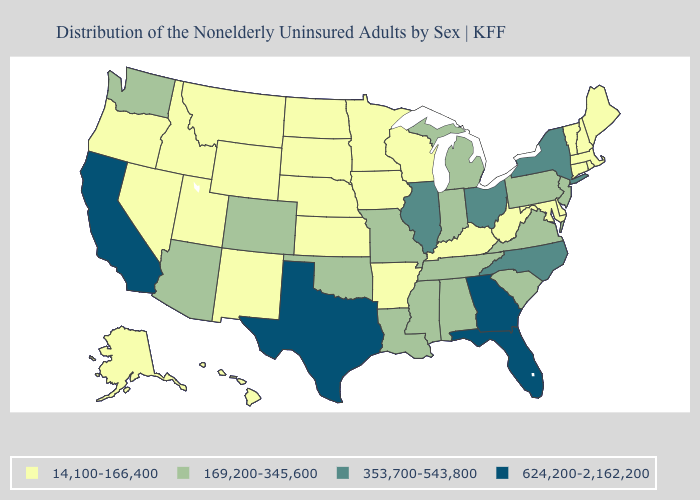What is the value of Arkansas?
Answer briefly. 14,100-166,400. Which states hav the highest value in the West?
Be succinct. California. Does California have the highest value in the West?
Be succinct. Yes. Does Oklahoma have a higher value than Hawaii?
Short answer required. Yes. Does Massachusetts have the lowest value in the Northeast?
Concise answer only. Yes. Which states have the lowest value in the South?
Be succinct. Arkansas, Delaware, Kentucky, Maryland, West Virginia. Name the states that have a value in the range 624,200-2,162,200?
Quick response, please. California, Florida, Georgia, Texas. What is the highest value in the USA?
Quick response, please. 624,200-2,162,200. Does Iowa have a higher value than Montana?
Write a very short answer. No. Name the states that have a value in the range 14,100-166,400?
Keep it brief. Alaska, Arkansas, Connecticut, Delaware, Hawaii, Idaho, Iowa, Kansas, Kentucky, Maine, Maryland, Massachusetts, Minnesota, Montana, Nebraska, Nevada, New Hampshire, New Mexico, North Dakota, Oregon, Rhode Island, South Dakota, Utah, Vermont, West Virginia, Wisconsin, Wyoming. Name the states that have a value in the range 14,100-166,400?
Quick response, please. Alaska, Arkansas, Connecticut, Delaware, Hawaii, Idaho, Iowa, Kansas, Kentucky, Maine, Maryland, Massachusetts, Minnesota, Montana, Nebraska, Nevada, New Hampshire, New Mexico, North Dakota, Oregon, Rhode Island, South Dakota, Utah, Vermont, West Virginia, Wisconsin, Wyoming. What is the value of Idaho?
Keep it brief. 14,100-166,400. What is the lowest value in the South?
Short answer required. 14,100-166,400. Does Georgia have the lowest value in the USA?
Concise answer only. No. Among the states that border West Virginia , does Kentucky have the highest value?
Be succinct. No. 